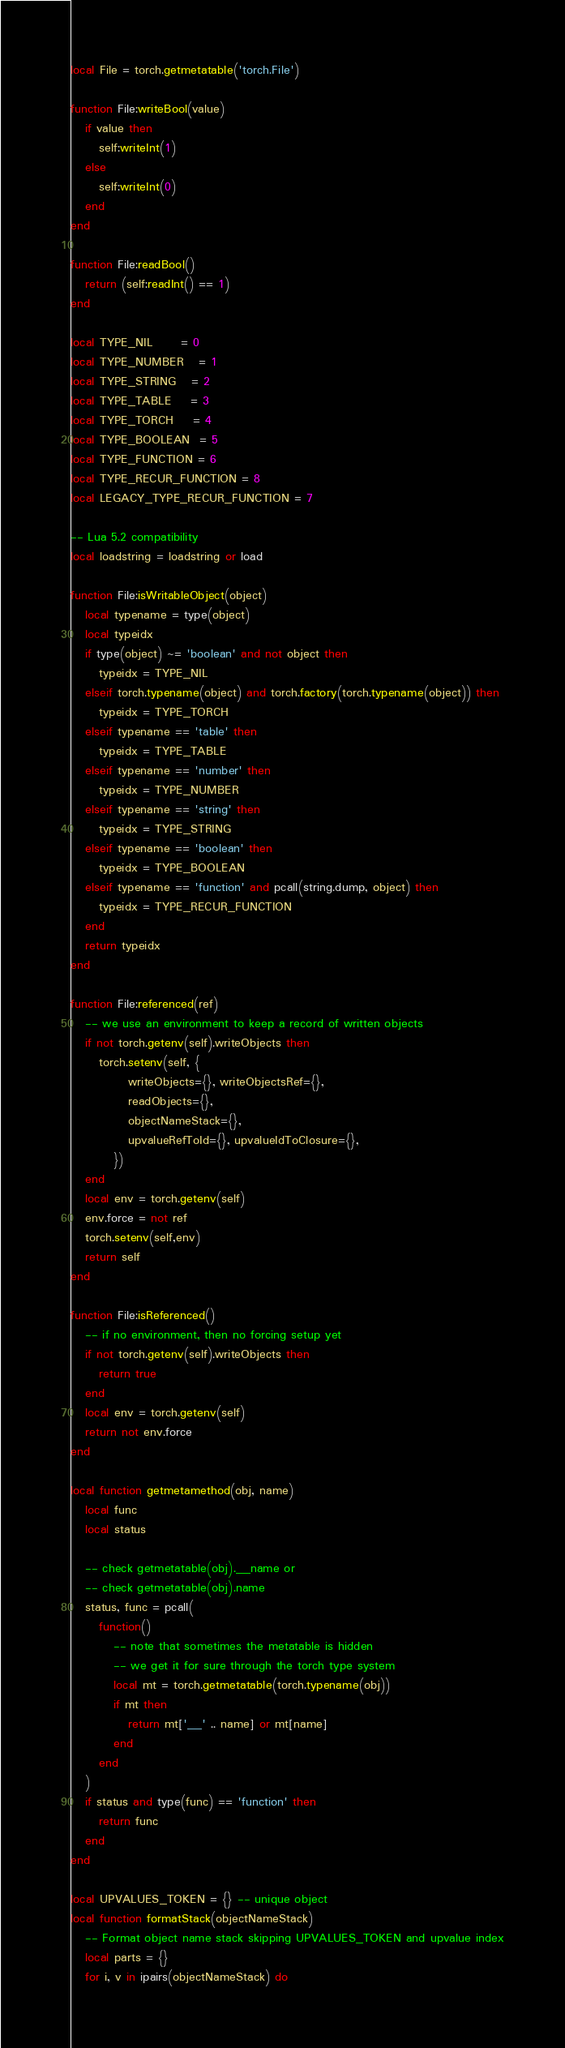Convert code to text. <code><loc_0><loc_0><loc_500><loc_500><_Lua_>local File = torch.getmetatable('torch.File')

function File:writeBool(value)
   if value then
      self:writeInt(1)
   else
      self:writeInt(0)
   end
end

function File:readBool()
   return (self:readInt() == 1)
end

local TYPE_NIL      = 0
local TYPE_NUMBER   = 1
local TYPE_STRING   = 2
local TYPE_TABLE    = 3
local TYPE_TORCH    = 4
local TYPE_BOOLEAN  = 5
local TYPE_FUNCTION = 6
local TYPE_RECUR_FUNCTION = 8
local LEGACY_TYPE_RECUR_FUNCTION = 7

-- Lua 5.2 compatibility
local loadstring = loadstring or load

function File:isWritableObject(object)
   local typename = type(object)
   local typeidx
   if type(object) ~= 'boolean' and not object then
      typeidx = TYPE_NIL
   elseif torch.typename(object) and torch.factory(torch.typename(object)) then
      typeidx = TYPE_TORCH
   elseif typename == 'table' then
      typeidx = TYPE_TABLE
   elseif typename == 'number' then
      typeidx = TYPE_NUMBER
   elseif typename == 'string' then
      typeidx = TYPE_STRING
   elseif typename == 'boolean' then
      typeidx = TYPE_BOOLEAN
   elseif typename == 'function' and pcall(string.dump, object) then
      typeidx = TYPE_RECUR_FUNCTION
   end
   return typeidx
end

function File:referenced(ref)
   -- we use an environment to keep a record of written objects
   if not torch.getenv(self).writeObjects then
      torch.setenv(self, {
            writeObjects={}, writeObjectsRef={},
            readObjects={},
            objectNameStack={},
            upvalueRefToId={}, upvalueIdToClosure={},
         })
   end
   local env = torch.getenv(self)
   env.force = not ref
   torch.setenv(self,env)
   return self
end

function File:isReferenced()
   -- if no environment, then no forcing setup yet
   if not torch.getenv(self).writeObjects then
      return true
   end
   local env = torch.getenv(self)
   return not env.force
end

local function getmetamethod(obj, name)
   local func
   local status

   -- check getmetatable(obj).__name or
   -- check getmetatable(obj).name
   status, func = pcall(
      function()
         -- note that sometimes the metatable is hidden
         -- we get it for sure through the torch type system
         local mt = torch.getmetatable(torch.typename(obj))
         if mt then
            return mt['__' .. name] or mt[name]
         end
      end
   )
   if status and type(func) == 'function' then
      return func
   end
end

local UPVALUES_TOKEN = {} -- unique object
local function formatStack(objectNameStack)
   -- Format object name stack skipping UPVALUES_TOKEN and upvalue index
   local parts = {}
   for i, v in ipairs(objectNameStack) do</code> 